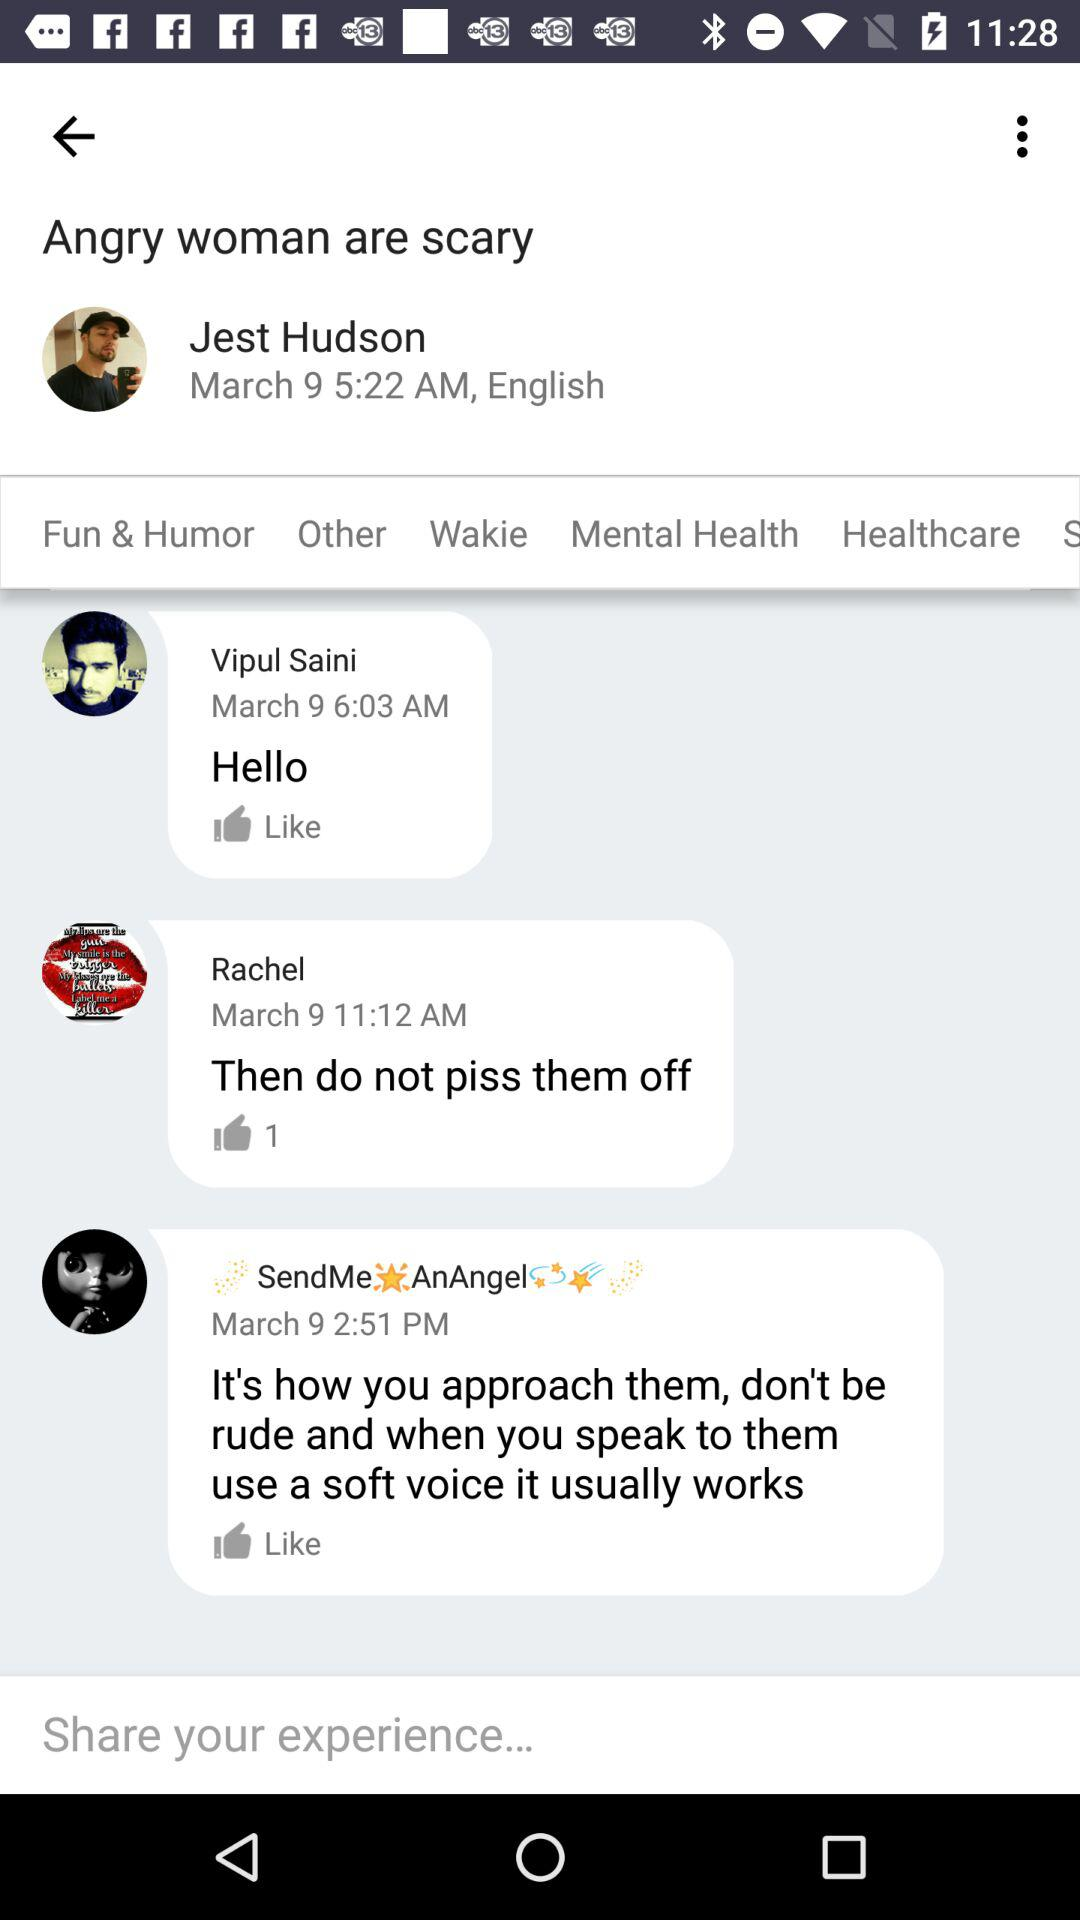What is the user name? The user names are Jest Hudson, Vipul Saini and Rachel. 